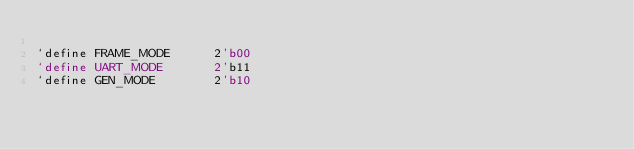<code> <loc_0><loc_0><loc_500><loc_500><_C_>
`define FRAME_MODE      2'b00
`define UART_MODE       2'b11
`define GEN_MODE        2'b10</code> 